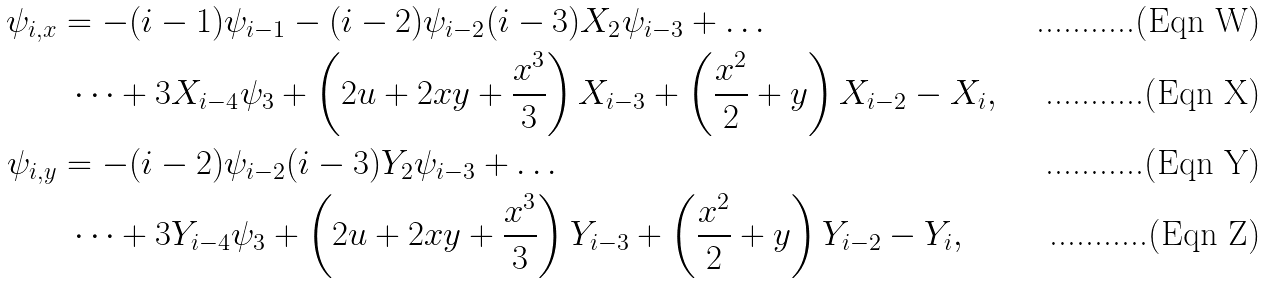<formula> <loc_0><loc_0><loc_500><loc_500>\psi _ { i , x } & = - ( i - 1 ) \psi _ { i - 1 } - ( i - 2 ) \psi _ { i - 2 } ( i - 3 ) X _ { 2 } \psi _ { i - 3 } + \dots \\ & \ \dots + 3 X _ { i - 4 } \psi _ { 3 } + \left ( 2 u + 2 x y + \frac { x ^ { 3 } } { 3 } \right ) X _ { i - 3 } + \left ( \frac { x ^ { 2 } } { 2 } + y \right ) X _ { i - 2 } - X _ { i } , \\ \psi _ { i , y } & = - ( i - 2 ) \psi _ { i - 2 } ( i - 3 ) Y _ { 2 } \psi _ { i - 3 } + \dots \\ & \ \dots + 3 Y _ { i - 4 } \psi _ { 3 } + \left ( 2 u + 2 x y + \frac { x ^ { 3 } } { 3 } \right ) Y _ { i - 3 } + \left ( \frac { x ^ { 2 } } { 2 } + y \right ) Y _ { i - 2 } - Y _ { i } ,</formula> 